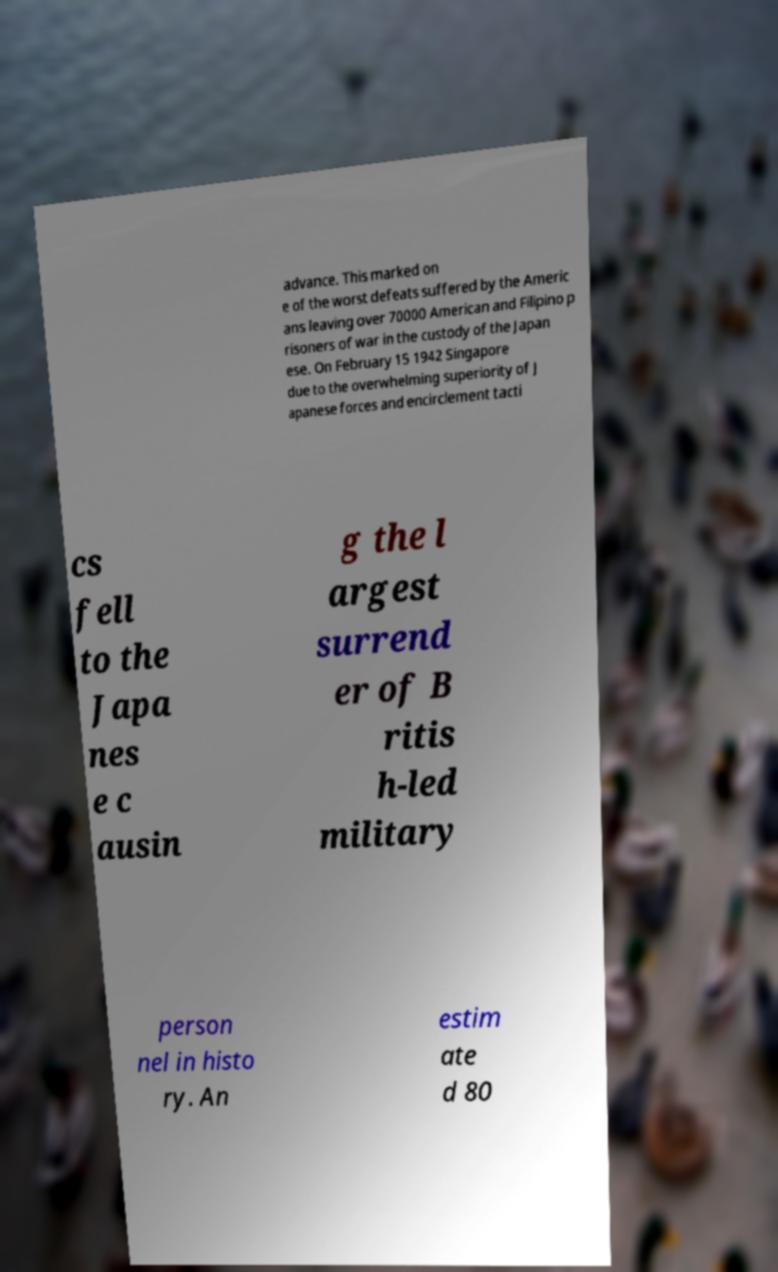For documentation purposes, I need the text within this image transcribed. Could you provide that? advance. This marked on e of the worst defeats suffered by the Americ ans leaving over 70000 American and Filipino p risoners of war in the custody of the Japan ese. On February 15 1942 Singapore due to the overwhelming superiority of J apanese forces and encirclement tacti cs fell to the Japa nes e c ausin g the l argest surrend er of B ritis h-led military person nel in histo ry. An estim ate d 80 